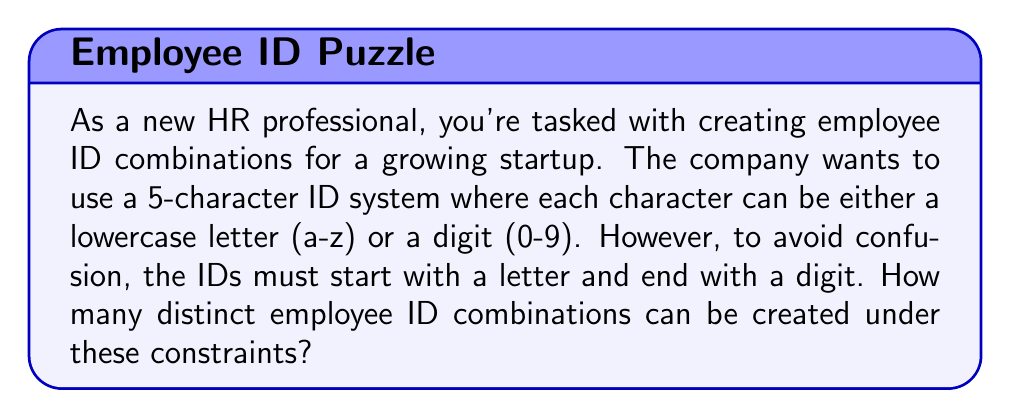Could you help me with this problem? Let's break this down step-by-step:

1) The ID has 5 characters in total.

2) The first character must be a letter:
   - There are 26 choices for the first character (a-z)

3) The last character must be a digit:
   - There are 10 choices for the last character (0-9)

4) For the middle three characters, we can use either letters or digits:
   - For each of these positions, we have 36 choices (26 letters + 10 digits)

5) Now, we can apply the multiplication principle. The total number of combinations is:

   $$ 26 \times 36 \times 36 \times 36 \times 10 $$

6) Let's calculate this:
   $$ 26 \times 36^3 \times 10 = 26 \times 46,656 \times 10 = 12,130,560 $$

Therefore, the total number of distinct employee ID combinations that satisfy the given constraints is 12,130,560.
Answer: 12,130,560 